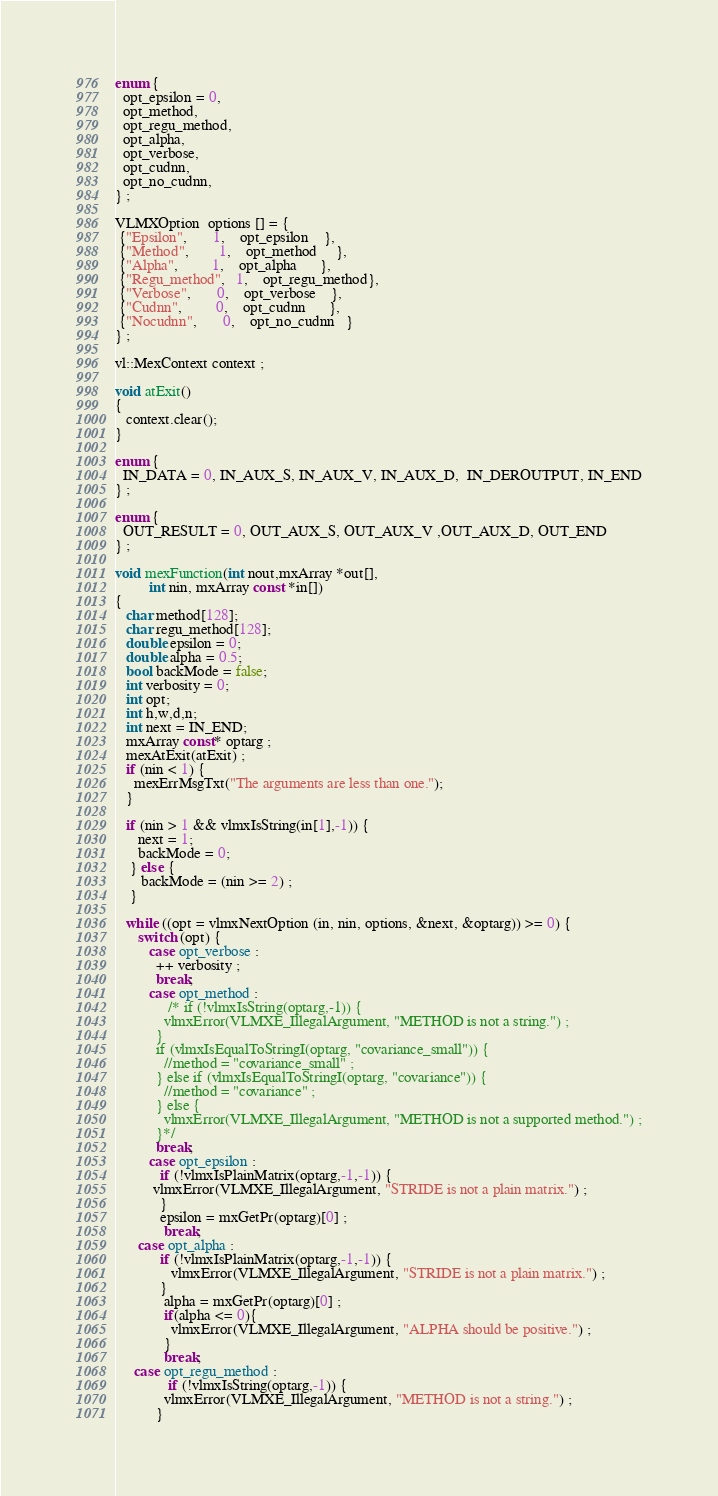<code> <loc_0><loc_0><loc_500><loc_500><_Cuda_>enum {
  opt_epsilon = 0,
  opt_method,
  opt_regu_method,
  opt_alpha,
  opt_verbose,
  opt_cudnn,
  opt_no_cudnn,
} ;

VLMXOption  options [] = {
 {"Epsilon",       1,    opt_epsilon    },
 {"Method",        1,    opt_method     },
 {"Alpha",         1,    opt_alpha      },
 {"Regu_method",   1,    opt_regu_method},
 {"Verbose",       0,    opt_verbose    },
 {"Cudnn",         0,    opt_cudnn      },
 {"Nocudnn",       0,    opt_no_cudnn   }
} ;

vl::MexContext context ;

void atExit()
{
   context.clear();
}

enum {
  IN_DATA = 0, IN_AUX_S, IN_AUX_V, IN_AUX_D,  IN_DEROUTPUT, IN_END
} ;

enum {
  OUT_RESULT = 0, OUT_AUX_S, OUT_AUX_V ,OUT_AUX_D, OUT_END
} ;

void mexFunction(int nout,mxArray *out[],
         int nin, mxArray const *in[])
{
   char method[128];
   char regu_method[128];
   double epsilon = 0;
   double alpha = 0.5;
   bool backMode = false;
   int verbosity = 0;
   int opt;
   int h,w,d,n;
   int next = IN_END;
   mxArray const* optarg ;
   mexAtExit(atExit) ;
   if (nin < 1) {
     mexErrMsgTxt("The arguments are less than one.");
   }
   
   if (nin > 1 && vlmxIsString(in[1],-1)) {
      next = 1;
      backMode = 0;
    } else {
       backMode = (nin >= 2) ;
    }

   while ((opt = vlmxNextOption (in, nin, options, &next, &optarg)) >= 0) {
      switch (opt) {
         case opt_verbose :
           ++ verbosity ;
           break;
         case opt_method :
              /* if (!vlmxIsString(optarg,-1)) {
             vlmxError(VLMXE_IllegalArgument, "METHOD is not a string.") ;
           }
           if (vlmxIsEqualToStringI(optarg, "covariance_small")) {
             //method = "covariance_small" ;
           } else if (vlmxIsEqualToStringI(optarg, "covariance")) {
             //method = "covariance" ;
           } else {
             vlmxError(VLMXE_IllegalArgument, "METHOD is not a supported method.") ;
           }*/
           break;
         case opt_epsilon :
            if (!vlmxIsPlainMatrix(optarg,-1,-1)) {
          vlmxError(VLMXE_IllegalArgument, "STRIDE is not a plain matrix.") ;
            }
            epsilon = mxGetPr(optarg)[0] ;
             break;
      case opt_alpha :
            if (!vlmxIsPlainMatrix(optarg,-1,-1)) {
               vlmxError(VLMXE_IllegalArgument, "STRIDE is not a plain matrix.") ;
            }
             alpha = mxGetPr(optarg)[0] ;
             if(alpha <= 0){
               vlmxError(VLMXE_IllegalArgument, "ALPHA should be positive.") ;
             }
             break;
     case opt_regu_method :
              if (!vlmxIsString(optarg,-1)) {
             vlmxError(VLMXE_IllegalArgument, "METHOD is not a string.") ;
           }</code> 